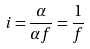<formula> <loc_0><loc_0><loc_500><loc_500>i = \frac { \alpha } { \alpha f } = \frac { 1 } { f }</formula> 